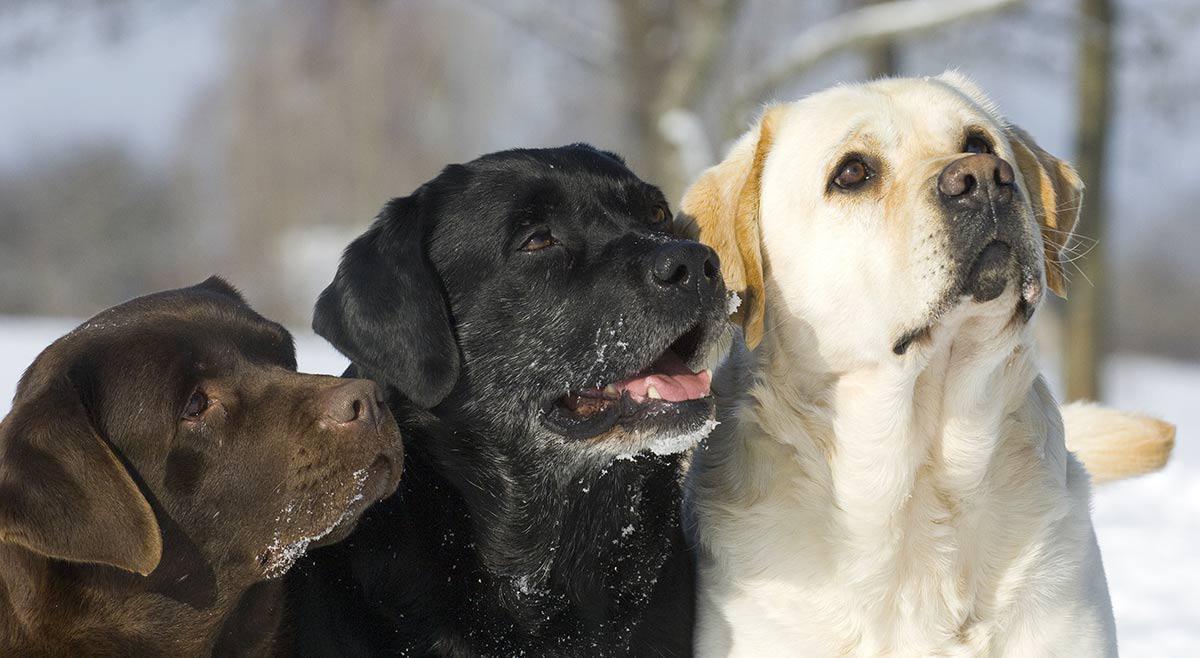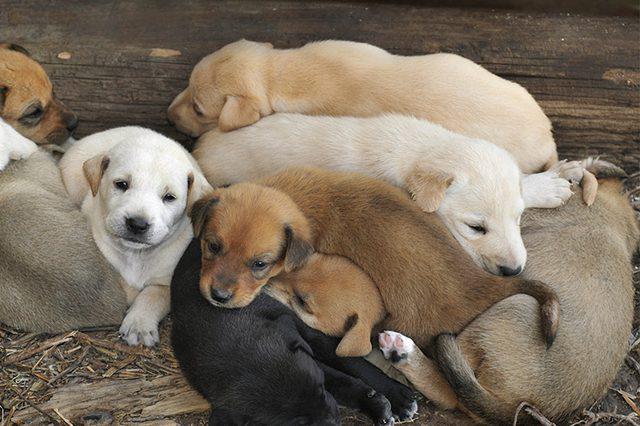The first image is the image on the left, the second image is the image on the right. Considering the images on both sides, is "labs are sitting near a river" valid? Answer yes or no. No. The first image is the image on the left, the second image is the image on the right. For the images displayed, is the sentence "The image on the right has three dogs that are all sitting." factually correct? Answer yes or no. No. 